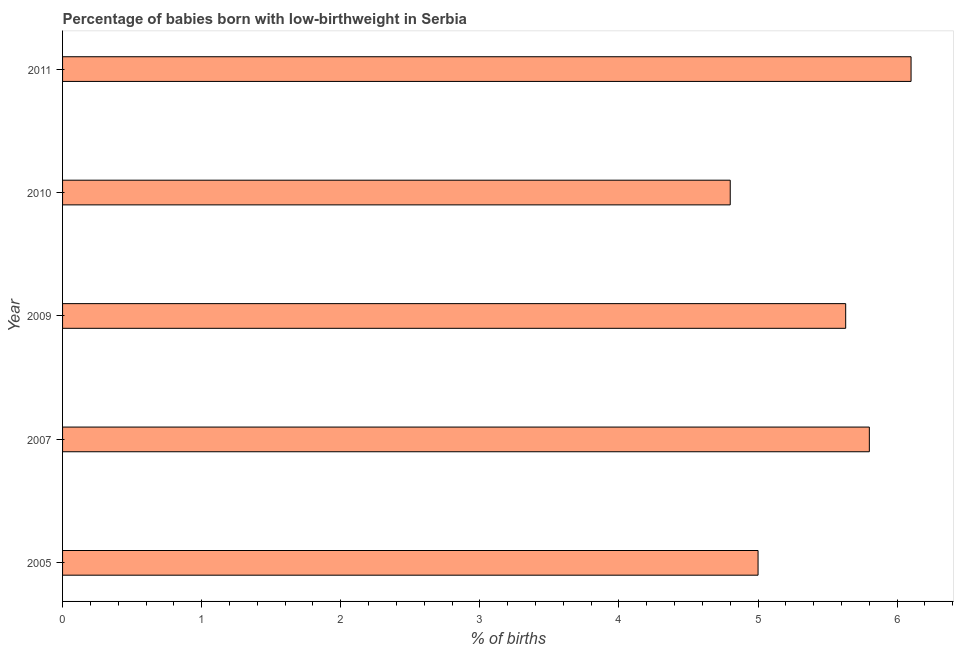Does the graph contain any zero values?
Make the answer very short. No. What is the title of the graph?
Provide a succinct answer. Percentage of babies born with low-birthweight in Serbia. What is the label or title of the X-axis?
Offer a terse response. % of births. What is the percentage of babies who were born with low-birthweight in 2009?
Give a very brief answer. 5.63. In which year was the percentage of babies who were born with low-birthweight minimum?
Your answer should be compact. 2010. What is the sum of the percentage of babies who were born with low-birthweight?
Provide a succinct answer. 27.33. What is the difference between the percentage of babies who were born with low-birthweight in 2005 and 2011?
Give a very brief answer. -1.1. What is the average percentage of babies who were born with low-birthweight per year?
Offer a very short reply. 5.47. What is the median percentage of babies who were born with low-birthweight?
Ensure brevity in your answer.  5.63. In how many years, is the percentage of babies who were born with low-birthweight greater than 2.8 %?
Provide a short and direct response. 5. What is the ratio of the percentage of babies who were born with low-birthweight in 2009 to that in 2011?
Your answer should be compact. 0.92. What is the difference between the highest and the second highest percentage of babies who were born with low-birthweight?
Provide a succinct answer. 0.3. How many bars are there?
Provide a short and direct response. 5. How many years are there in the graph?
Ensure brevity in your answer.  5. What is the % of births in 2007?
Keep it short and to the point. 5.8. What is the % of births in 2009?
Make the answer very short. 5.63. What is the % of births in 2011?
Make the answer very short. 6.1. What is the difference between the % of births in 2005 and 2007?
Offer a terse response. -0.8. What is the difference between the % of births in 2005 and 2009?
Make the answer very short. -0.63. What is the difference between the % of births in 2005 and 2010?
Your answer should be compact. 0.2. What is the difference between the % of births in 2005 and 2011?
Give a very brief answer. -1.1. What is the difference between the % of births in 2007 and 2009?
Make the answer very short. 0.17. What is the difference between the % of births in 2007 and 2010?
Provide a succinct answer. 1. What is the difference between the % of births in 2009 and 2010?
Offer a very short reply. 0.83. What is the difference between the % of births in 2009 and 2011?
Offer a very short reply. -0.47. What is the ratio of the % of births in 2005 to that in 2007?
Make the answer very short. 0.86. What is the ratio of the % of births in 2005 to that in 2009?
Ensure brevity in your answer.  0.89. What is the ratio of the % of births in 2005 to that in 2010?
Offer a very short reply. 1.04. What is the ratio of the % of births in 2005 to that in 2011?
Keep it short and to the point. 0.82. What is the ratio of the % of births in 2007 to that in 2009?
Offer a very short reply. 1.03. What is the ratio of the % of births in 2007 to that in 2010?
Your answer should be very brief. 1.21. What is the ratio of the % of births in 2007 to that in 2011?
Offer a terse response. 0.95. What is the ratio of the % of births in 2009 to that in 2010?
Give a very brief answer. 1.17. What is the ratio of the % of births in 2009 to that in 2011?
Your answer should be very brief. 0.92. What is the ratio of the % of births in 2010 to that in 2011?
Keep it short and to the point. 0.79. 